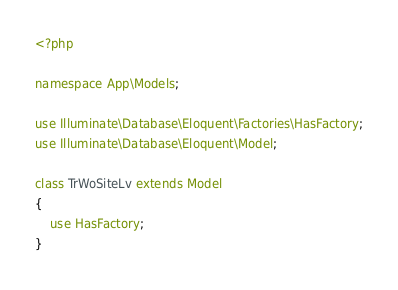<code> <loc_0><loc_0><loc_500><loc_500><_PHP_><?php

namespace App\Models;

use Illuminate\Database\Eloquent\Factories\HasFactory;
use Illuminate\Database\Eloquent\Model;

class TrWoSiteLv extends Model
{
    use HasFactory;
}
</code> 